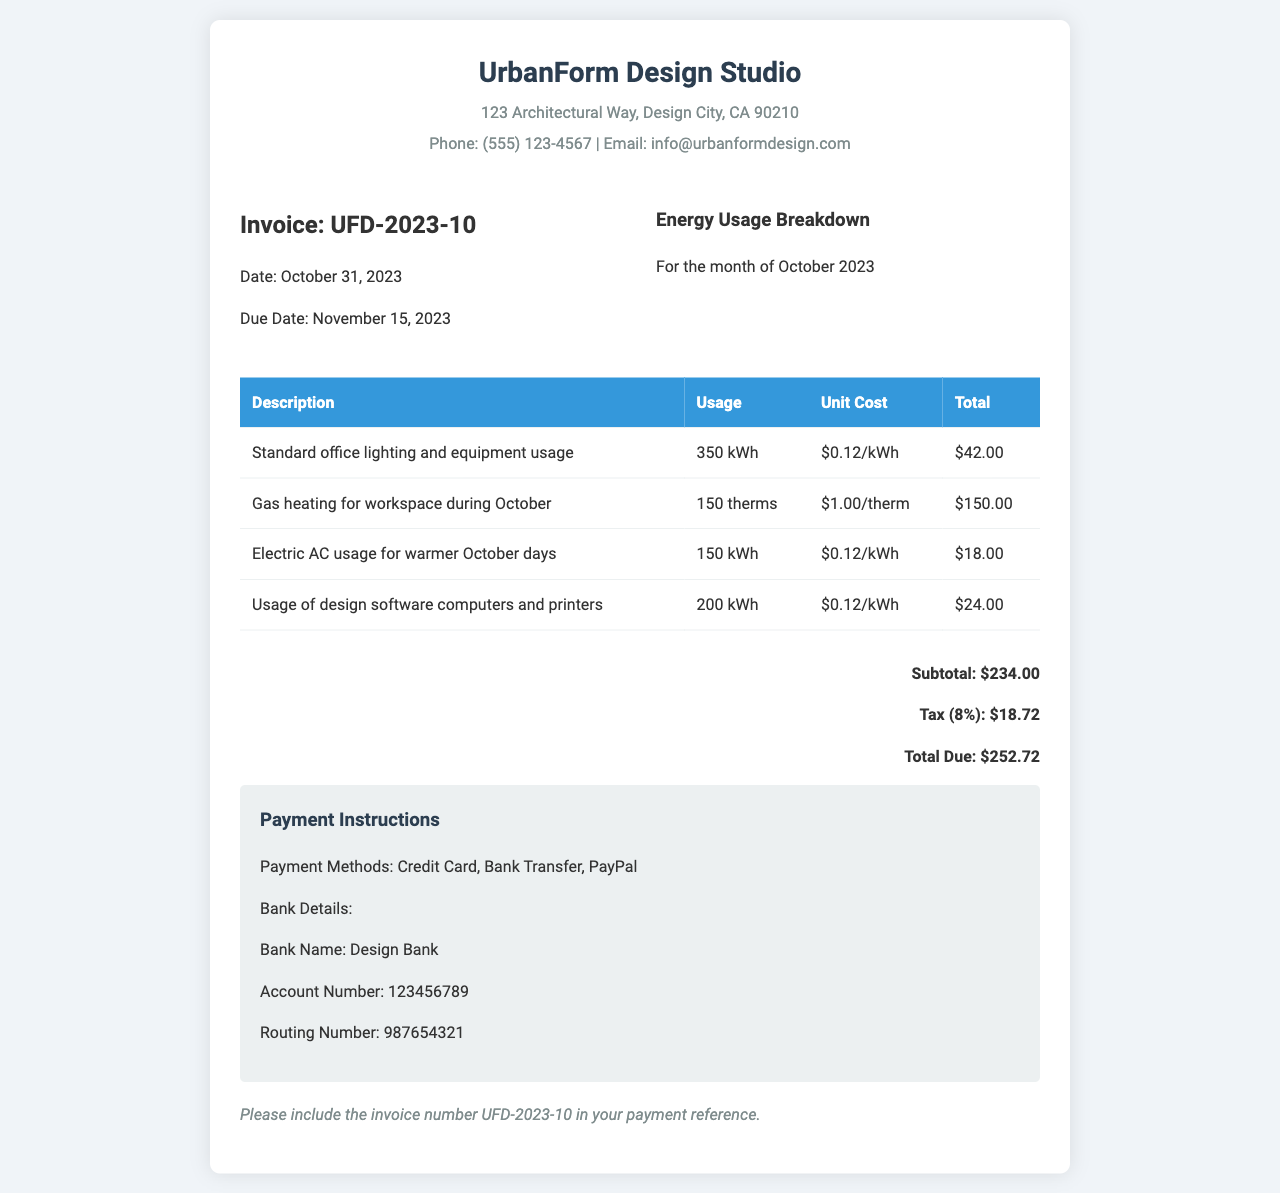What is the invoice number? The invoice number is stated in the document as a unique identifier for the billing.
Answer: UFD-2023-10 What is the total amount due? The total amount due is the final sum that needs to be paid, which is calculated after tax.
Answer: $252.72 How many kWh were used for standard office lighting and equipment? This information specifies the energy consumption for office operations.
Answer: 350 kWh What is the unit cost for gas heating? The unit cost reflects the price charged for each therm of gas heating used.
Answer: $1.00/therm What is the tax percentage applied to the subtotal? The tax percentage is a standard rate applied to the subtotal amount before total calculation.
Answer: 8% What is the subtotal amount before tax? The subtotal represents the total of all items before any taxes are included.
Answer: $234.00 What date is the payment due? The due date indicates when the payment must be completed by the client.
Answer: November 15, 2023 What type of workspace is this invoice for? The document specifies the nature of the establishment that the invoice is addressing.
Answer: Design studio What methods of payment are accepted? The methods of payment outline how the client can settle the invoice amount.
Answer: Credit Card, Bank Transfer, PayPal 